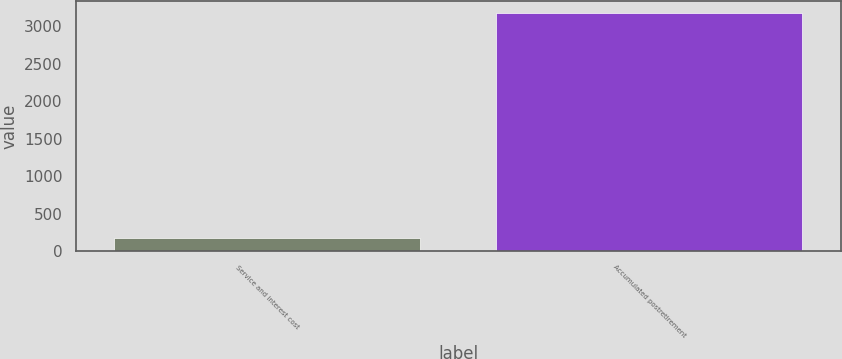Convert chart. <chart><loc_0><loc_0><loc_500><loc_500><bar_chart><fcel>Service and interest cost<fcel>Accumulated postretirement<nl><fcel>180<fcel>3179<nl></chart> 